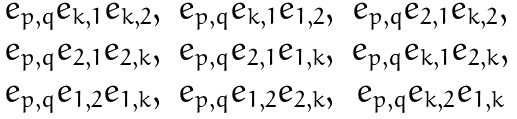Convert formula to latex. <formula><loc_0><loc_0><loc_500><loc_500>\begin{matrix} e _ { p , q } e _ { k , 1 } e _ { k , 2 } , & e _ { p , q } e _ { k , 1 } e _ { 1 , 2 } , & e _ { p , q } e _ { 2 , 1 } e _ { k , 2 } , \\ e _ { p , q } e _ { 2 , 1 } e _ { 2 , k } , & e _ { p , q } e _ { 2 , 1 } e _ { 1 , k } , & e _ { p , q } e _ { k , 1 } e _ { 2 , k } , \\ e _ { p , q } e _ { 1 , 2 } e _ { 1 , k } , & e _ { p , q } e _ { 1 , 2 } e _ { 2 , k } , & e _ { p , q } e _ { k , 2 } e _ { 1 , k } \end{matrix}</formula> 